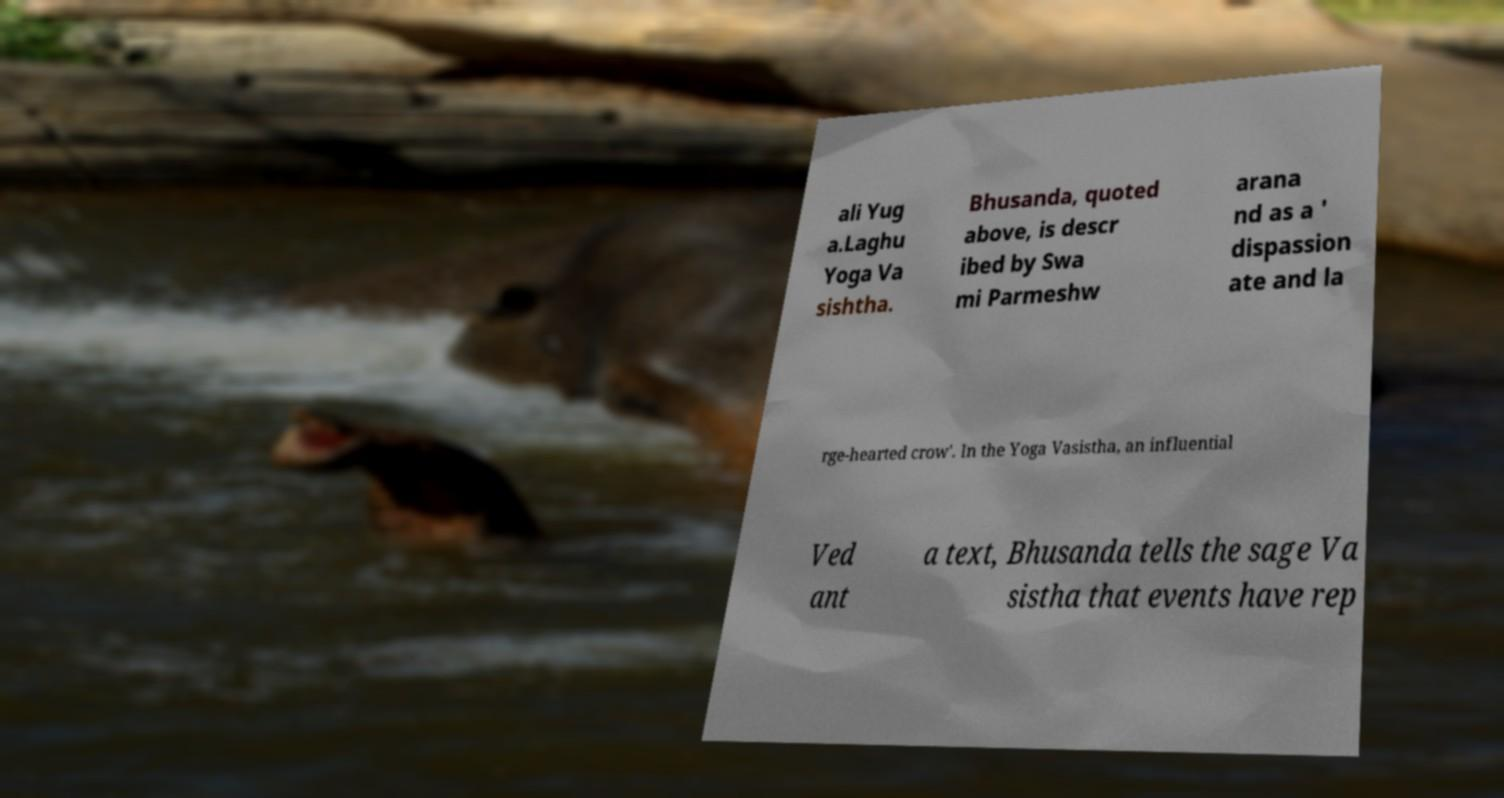Please identify and transcribe the text found in this image. ali Yug a.Laghu Yoga Va sishtha. Bhusanda, quoted above, is descr ibed by Swa mi Parmeshw arana nd as a ' dispassion ate and la rge-hearted crow'. In the Yoga Vasistha, an influential Ved ant a text, Bhusanda tells the sage Va sistha that events have rep 